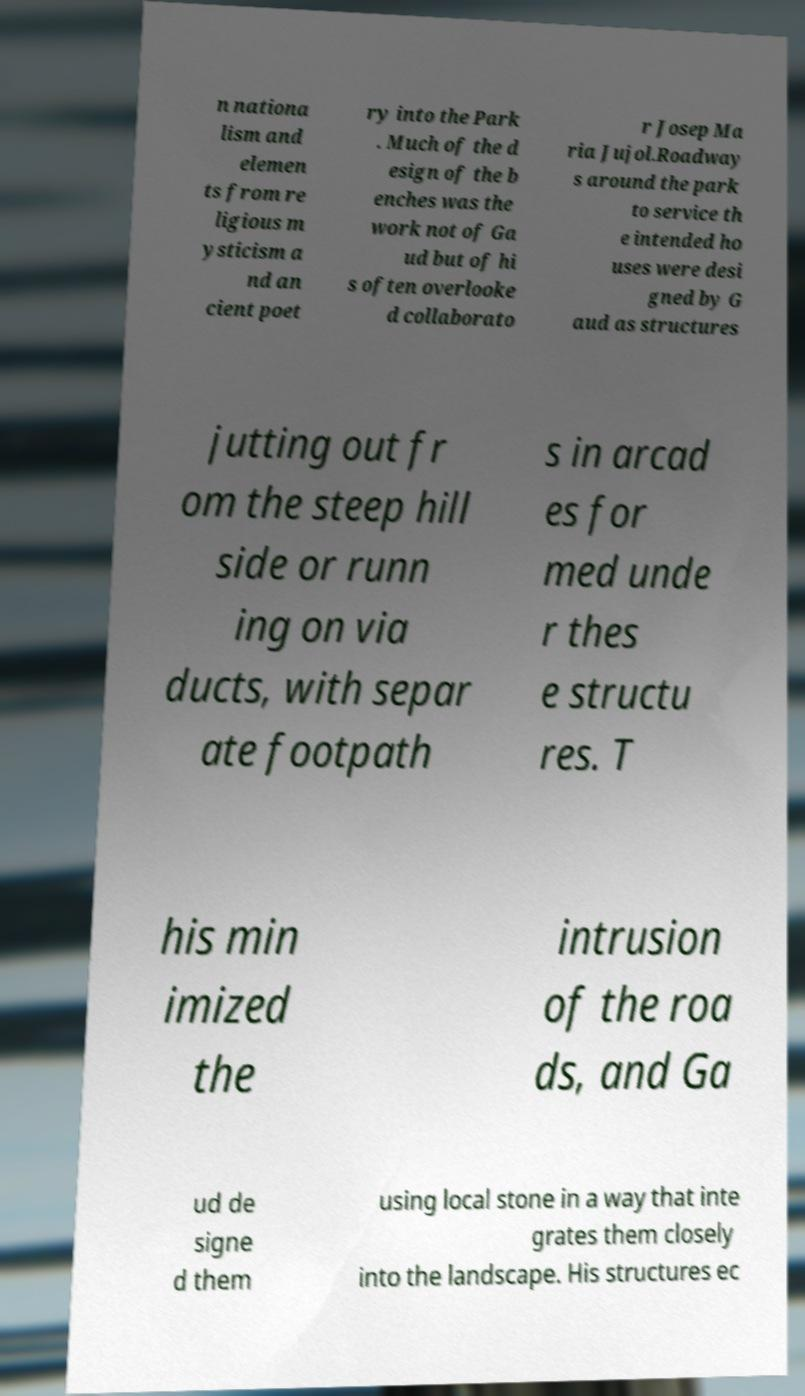Can you read and provide the text displayed in the image?This photo seems to have some interesting text. Can you extract and type it out for me? n nationa lism and elemen ts from re ligious m ysticism a nd an cient poet ry into the Park . Much of the d esign of the b enches was the work not of Ga ud but of hi s often overlooke d collaborato r Josep Ma ria Jujol.Roadway s around the park to service th e intended ho uses were desi gned by G aud as structures jutting out fr om the steep hill side or runn ing on via ducts, with separ ate footpath s in arcad es for med unde r thes e structu res. T his min imized the intrusion of the roa ds, and Ga ud de signe d them using local stone in a way that inte grates them closely into the landscape. His structures ec 